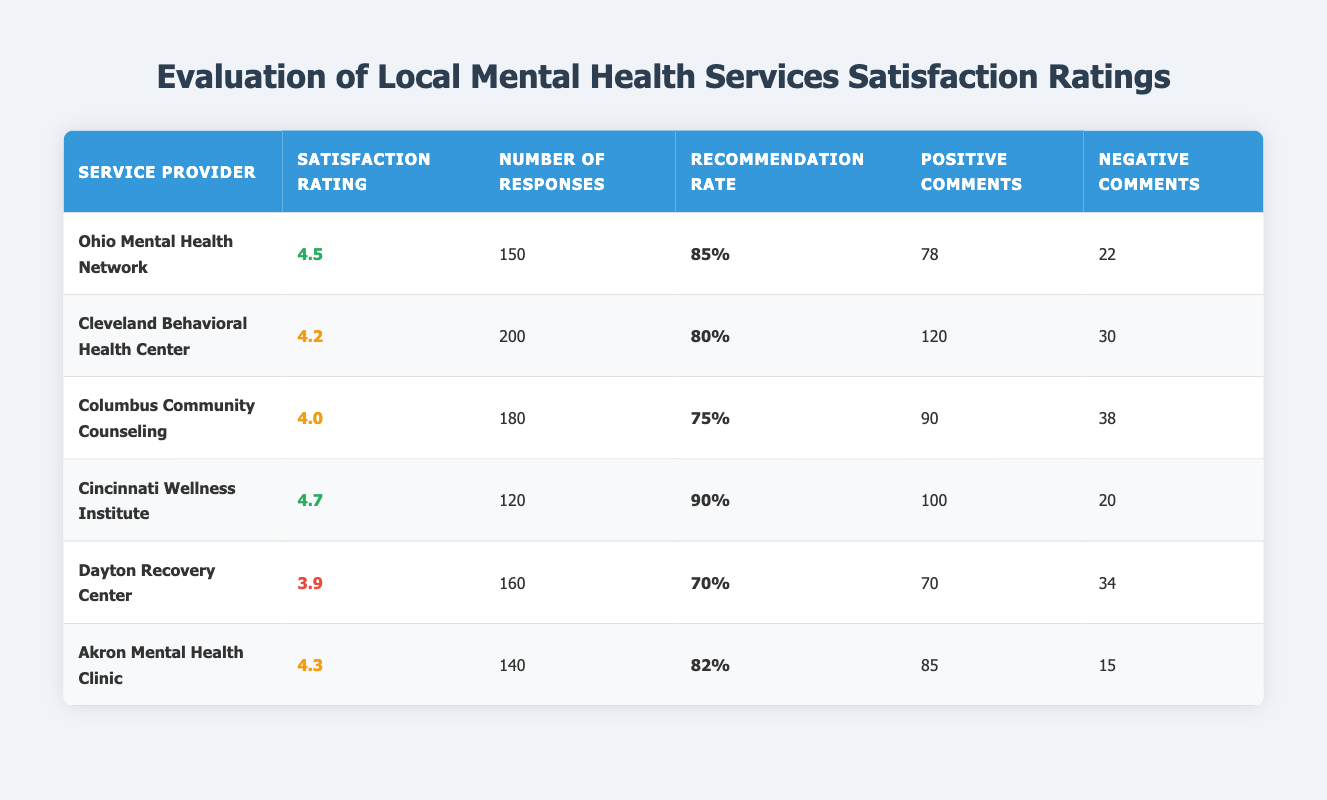What's the highest satisfaction rating among the service providers? The satisfaction ratings are as follows: Ohio Mental Health Network (4.5), Cleveland Behavioral Health Center (4.2), Columbus Community Counseling (4.0), Cincinnati Wellness Institute (4.7), Dayton Recovery Center (3.9), and Akron Mental Health Clinic (4.3). The highest rating is 4.7 for the Cincinnati Wellness Institute.
Answer: 4.7 How many total positive comments were received across all providers? To find the total positive comments, I will sum the positive comments: 78 + 120 + 90 + 100 + 70 + 85 = 543.
Answer: 543 What is the recommendation rate for the Columbus Community Counseling? The recommendation rate listed for Columbus Community Counseling is 75%.
Answer: 75% Is the satisfaction rating for the Dayton Recovery Center above or below 4.0? The satisfaction rating for Dayton Recovery Center is 3.9, which is below 4.0.
Answer: Below Which service provider had the lowest number of responses? The number of responses for each provider is as follows: Ohio Mental Health Network (150), Cleveland Behavioral Health Center (200), Columbus Community Counseling (180), Cincinnati Wellness Institute (120), Dayton Recovery Center (160), and Akron Mental Health Clinic (140). The lowest number is 120 for the Cincinnati Wellness Institute.
Answer: Cincinnati Wellness Institute What is the average satisfaction rating of all the providers? To calculate the average satisfaction rating, I add: 4.5 + 4.2 + 4.0 + 4.7 + 3.9 + 4.3 = 25.6. There are 6 providers, so the average is 25.6/6 = 4.27.
Answer: 4.27 Which service provider has the highest recommendation rate? The recommendation rates are: 85% (Ohio Mental Health Network), 80% (Cleveland Behavioral Health Center), 75% (Columbus Community Counseling), 90% (Cincinnati Wellness Institute), 70% (Dayton Recovery Center), and 82% (Akron Mental Health Clinic). The highest rate is 90% for the Cincinnati Wellness Institute.
Answer: Cincinnati Wellness Institute How many more negative comments did the Cleveland Behavioral Health Center receive compared to the Akron Mental Health Clinic? Cleveland Behavioral Health Center received 30 negative comments, while Akron Mental Health Clinic received 15. The difference is 30 - 15 = 15.
Answer: 15 Is the total number of responses greater than 1000 across all providers? Adding the number of responses gives: 150 + 200 + 180 + 120 + 160 + 140 = 1050. Since 1050 is greater than 1000, the answer is yes.
Answer: Yes Which service provider received the most comments overall? To find this, I will sum positive and negative comments for each provider. Ohio Mental Health Network: 78 + 22 = 100, Cleveland Behavioral Health Center: 120 + 30 = 150, Columbus Community Counseling: 90 + 38 = 128, Cincinnati Wellness Institute: 100 + 20 = 120, Dayton Recovery Center: 70 + 34 = 104, Akron Mental Health Clinic: 85 + 15 = 100. The highest total is 150 for Cleveland Behavioral Health Center.
Answer: Cleveland Behavioral Health Center How do the positive comments compare between the service providers with the highest and lowest satisfaction ratings? The Cincinnati Wellness Institute (highest rating at 4.7) received 100 positive comments, while the Dayton Recovery Center (lowest rating at 3.9) received 70 positive comments. The difference is 100 - 70 = 30 more positive comments for Cincinnati Wellness Institute.
Answer: 30 more positive comments 